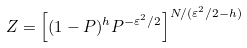<formula> <loc_0><loc_0><loc_500><loc_500>Z = \left [ ( 1 - P ) ^ { h } P ^ { - \varepsilon ^ { 2 } / 2 } \right ] ^ { N / ( \varepsilon ^ { 2 } / 2 - h ) }</formula> 